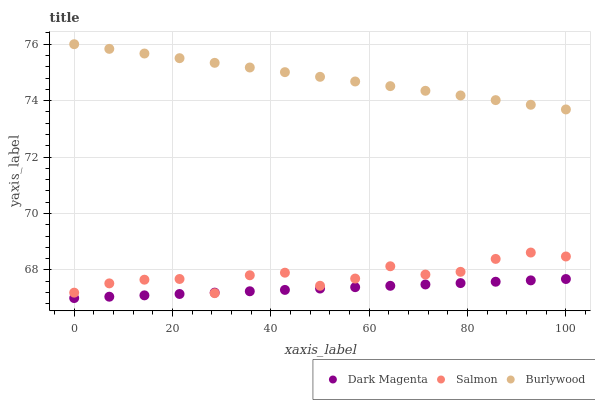Does Dark Magenta have the minimum area under the curve?
Answer yes or no. Yes. Does Burlywood have the maximum area under the curve?
Answer yes or no. Yes. Does Salmon have the minimum area under the curve?
Answer yes or no. No. Does Salmon have the maximum area under the curve?
Answer yes or no. No. Is Burlywood the smoothest?
Answer yes or no. Yes. Is Salmon the roughest?
Answer yes or no. Yes. Is Dark Magenta the smoothest?
Answer yes or no. No. Is Dark Magenta the roughest?
Answer yes or no. No. Does Dark Magenta have the lowest value?
Answer yes or no. Yes. Does Salmon have the lowest value?
Answer yes or no. No. Does Burlywood have the highest value?
Answer yes or no. Yes. Does Salmon have the highest value?
Answer yes or no. No. Is Salmon less than Burlywood?
Answer yes or no. Yes. Is Burlywood greater than Dark Magenta?
Answer yes or no. Yes. Does Salmon intersect Dark Magenta?
Answer yes or no. Yes. Is Salmon less than Dark Magenta?
Answer yes or no. No. Is Salmon greater than Dark Magenta?
Answer yes or no. No. Does Salmon intersect Burlywood?
Answer yes or no. No. 